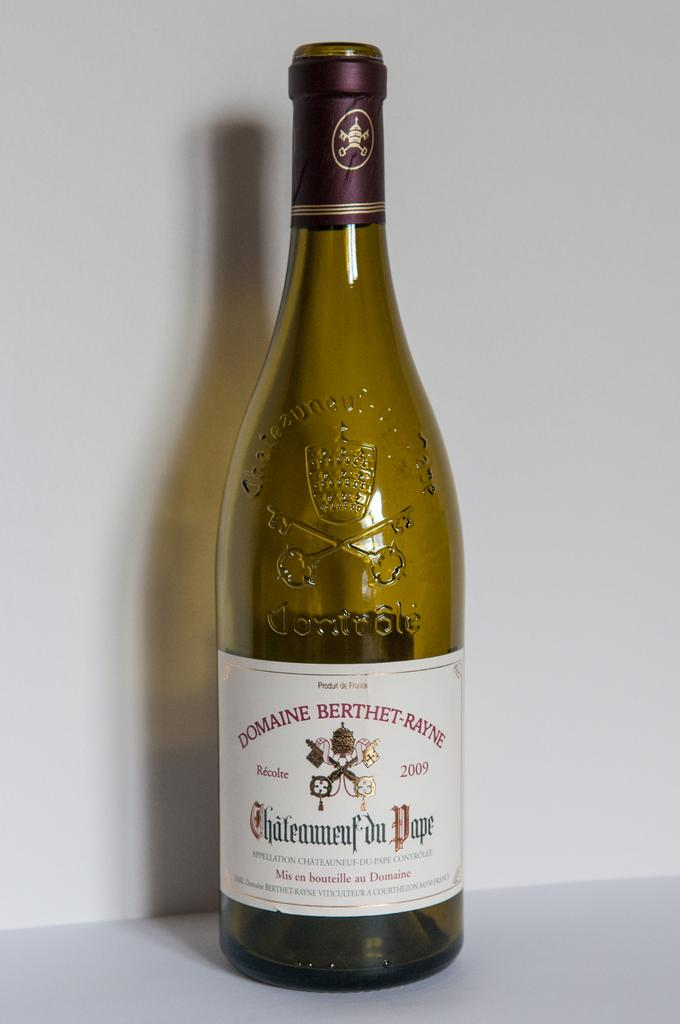<image>
Write a terse but informative summary of the picture. A light greenish amber glass bottle with a white Domaine Berthet-Rayne label from 2009. 